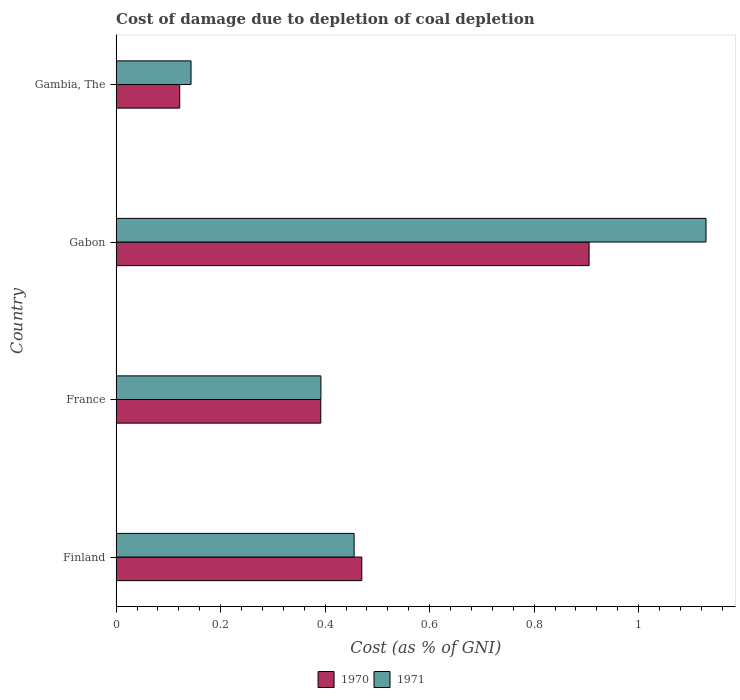How many different coloured bars are there?
Give a very brief answer. 2. Are the number of bars on each tick of the Y-axis equal?
Give a very brief answer. Yes. How many bars are there on the 1st tick from the top?
Offer a terse response. 2. How many bars are there on the 4th tick from the bottom?
Provide a short and direct response. 2. What is the label of the 2nd group of bars from the top?
Ensure brevity in your answer.  Gabon. What is the cost of damage caused due to coal depletion in 1971 in Gambia, The?
Keep it short and to the point. 0.14. Across all countries, what is the maximum cost of damage caused due to coal depletion in 1970?
Your answer should be compact. 0.91. Across all countries, what is the minimum cost of damage caused due to coal depletion in 1970?
Ensure brevity in your answer.  0.12. In which country was the cost of damage caused due to coal depletion in 1971 maximum?
Keep it short and to the point. Gabon. In which country was the cost of damage caused due to coal depletion in 1971 minimum?
Your answer should be compact. Gambia, The. What is the total cost of damage caused due to coal depletion in 1970 in the graph?
Keep it short and to the point. 1.89. What is the difference between the cost of damage caused due to coal depletion in 1970 in France and that in Gambia, The?
Your response must be concise. 0.27. What is the difference between the cost of damage caused due to coal depletion in 1971 in Gambia, The and the cost of damage caused due to coal depletion in 1970 in France?
Provide a succinct answer. -0.25. What is the average cost of damage caused due to coal depletion in 1971 per country?
Provide a short and direct response. 0.53. What is the difference between the cost of damage caused due to coal depletion in 1971 and cost of damage caused due to coal depletion in 1970 in Finland?
Provide a short and direct response. -0.01. In how many countries, is the cost of damage caused due to coal depletion in 1971 greater than 0.44 %?
Provide a short and direct response. 2. What is the ratio of the cost of damage caused due to coal depletion in 1970 in France to that in Gabon?
Keep it short and to the point. 0.43. Is the cost of damage caused due to coal depletion in 1970 in France less than that in Gambia, The?
Provide a succinct answer. No. What is the difference between the highest and the second highest cost of damage caused due to coal depletion in 1970?
Provide a short and direct response. 0.43. What is the difference between the highest and the lowest cost of damage caused due to coal depletion in 1971?
Offer a terse response. 0.99. In how many countries, is the cost of damage caused due to coal depletion in 1971 greater than the average cost of damage caused due to coal depletion in 1971 taken over all countries?
Your answer should be very brief. 1. How many bars are there?
Your answer should be compact. 8. Are all the bars in the graph horizontal?
Your response must be concise. Yes. Are the values on the major ticks of X-axis written in scientific E-notation?
Ensure brevity in your answer.  No. How many legend labels are there?
Keep it short and to the point. 2. How are the legend labels stacked?
Offer a terse response. Horizontal. What is the title of the graph?
Offer a very short reply. Cost of damage due to depletion of coal depletion. Does "2013" appear as one of the legend labels in the graph?
Offer a very short reply. No. What is the label or title of the X-axis?
Your answer should be very brief. Cost (as % of GNI). What is the Cost (as % of GNI) of 1970 in Finland?
Offer a very short reply. 0.47. What is the Cost (as % of GNI) in 1971 in Finland?
Offer a very short reply. 0.46. What is the Cost (as % of GNI) of 1970 in France?
Keep it short and to the point. 0.39. What is the Cost (as % of GNI) of 1971 in France?
Provide a succinct answer. 0.39. What is the Cost (as % of GNI) in 1970 in Gabon?
Your answer should be compact. 0.91. What is the Cost (as % of GNI) of 1971 in Gabon?
Make the answer very short. 1.13. What is the Cost (as % of GNI) in 1970 in Gambia, The?
Your response must be concise. 0.12. What is the Cost (as % of GNI) of 1971 in Gambia, The?
Make the answer very short. 0.14. Across all countries, what is the maximum Cost (as % of GNI) in 1970?
Your response must be concise. 0.91. Across all countries, what is the maximum Cost (as % of GNI) of 1971?
Keep it short and to the point. 1.13. Across all countries, what is the minimum Cost (as % of GNI) in 1970?
Your response must be concise. 0.12. Across all countries, what is the minimum Cost (as % of GNI) of 1971?
Ensure brevity in your answer.  0.14. What is the total Cost (as % of GNI) in 1970 in the graph?
Give a very brief answer. 1.89. What is the total Cost (as % of GNI) of 1971 in the graph?
Your answer should be very brief. 2.12. What is the difference between the Cost (as % of GNI) of 1970 in Finland and that in France?
Your answer should be very brief. 0.08. What is the difference between the Cost (as % of GNI) of 1971 in Finland and that in France?
Make the answer very short. 0.06. What is the difference between the Cost (as % of GNI) in 1970 in Finland and that in Gabon?
Make the answer very short. -0.43. What is the difference between the Cost (as % of GNI) in 1971 in Finland and that in Gabon?
Your response must be concise. -0.67. What is the difference between the Cost (as % of GNI) in 1970 in Finland and that in Gambia, The?
Your answer should be compact. 0.35. What is the difference between the Cost (as % of GNI) of 1971 in Finland and that in Gambia, The?
Ensure brevity in your answer.  0.31. What is the difference between the Cost (as % of GNI) of 1970 in France and that in Gabon?
Your response must be concise. -0.51. What is the difference between the Cost (as % of GNI) in 1971 in France and that in Gabon?
Your response must be concise. -0.74. What is the difference between the Cost (as % of GNI) of 1970 in France and that in Gambia, The?
Ensure brevity in your answer.  0.27. What is the difference between the Cost (as % of GNI) of 1971 in France and that in Gambia, The?
Your response must be concise. 0.25. What is the difference between the Cost (as % of GNI) in 1970 in Gabon and that in Gambia, The?
Offer a terse response. 0.78. What is the difference between the Cost (as % of GNI) of 1971 in Gabon and that in Gambia, The?
Your answer should be very brief. 0.99. What is the difference between the Cost (as % of GNI) of 1970 in Finland and the Cost (as % of GNI) of 1971 in France?
Give a very brief answer. 0.08. What is the difference between the Cost (as % of GNI) in 1970 in Finland and the Cost (as % of GNI) in 1971 in Gabon?
Provide a short and direct response. -0.66. What is the difference between the Cost (as % of GNI) in 1970 in Finland and the Cost (as % of GNI) in 1971 in Gambia, The?
Offer a very short reply. 0.33. What is the difference between the Cost (as % of GNI) of 1970 in France and the Cost (as % of GNI) of 1971 in Gabon?
Give a very brief answer. -0.74. What is the difference between the Cost (as % of GNI) of 1970 in France and the Cost (as % of GNI) of 1971 in Gambia, The?
Make the answer very short. 0.25. What is the difference between the Cost (as % of GNI) in 1970 in Gabon and the Cost (as % of GNI) in 1971 in Gambia, The?
Provide a short and direct response. 0.76. What is the average Cost (as % of GNI) in 1970 per country?
Ensure brevity in your answer.  0.47. What is the average Cost (as % of GNI) of 1971 per country?
Your answer should be compact. 0.53. What is the difference between the Cost (as % of GNI) in 1970 and Cost (as % of GNI) in 1971 in Finland?
Keep it short and to the point. 0.01. What is the difference between the Cost (as % of GNI) in 1970 and Cost (as % of GNI) in 1971 in France?
Offer a very short reply. -0. What is the difference between the Cost (as % of GNI) of 1970 and Cost (as % of GNI) of 1971 in Gabon?
Your answer should be compact. -0.22. What is the difference between the Cost (as % of GNI) in 1970 and Cost (as % of GNI) in 1971 in Gambia, The?
Your answer should be compact. -0.02. What is the ratio of the Cost (as % of GNI) of 1970 in Finland to that in France?
Your answer should be very brief. 1.2. What is the ratio of the Cost (as % of GNI) of 1971 in Finland to that in France?
Ensure brevity in your answer.  1.16. What is the ratio of the Cost (as % of GNI) of 1970 in Finland to that in Gabon?
Keep it short and to the point. 0.52. What is the ratio of the Cost (as % of GNI) in 1971 in Finland to that in Gabon?
Provide a short and direct response. 0.4. What is the ratio of the Cost (as % of GNI) of 1970 in Finland to that in Gambia, The?
Offer a very short reply. 3.86. What is the ratio of the Cost (as % of GNI) of 1971 in Finland to that in Gambia, The?
Your answer should be compact. 3.18. What is the ratio of the Cost (as % of GNI) of 1970 in France to that in Gabon?
Give a very brief answer. 0.43. What is the ratio of the Cost (as % of GNI) of 1971 in France to that in Gabon?
Offer a terse response. 0.35. What is the ratio of the Cost (as % of GNI) in 1970 in France to that in Gambia, The?
Offer a very short reply. 3.22. What is the ratio of the Cost (as % of GNI) of 1971 in France to that in Gambia, The?
Offer a terse response. 2.73. What is the ratio of the Cost (as % of GNI) in 1970 in Gabon to that in Gambia, The?
Your answer should be compact. 7.44. What is the ratio of the Cost (as % of GNI) in 1971 in Gabon to that in Gambia, The?
Give a very brief answer. 7.88. What is the difference between the highest and the second highest Cost (as % of GNI) of 1970?
Offer a terse response. 0.43. What is the difference between the highest and the second highest Cost (as % of GNI) of 1971?
Your response must be concise. 0.67. What is the difference between the highest and the lowest Cost (as % of GNI) in 1970?
Offer a terse response. 0.78. What is the difference between the highest and the lowest Cost (as % of GNI) of 1971?
Provide a short and direct response. 0.99. 